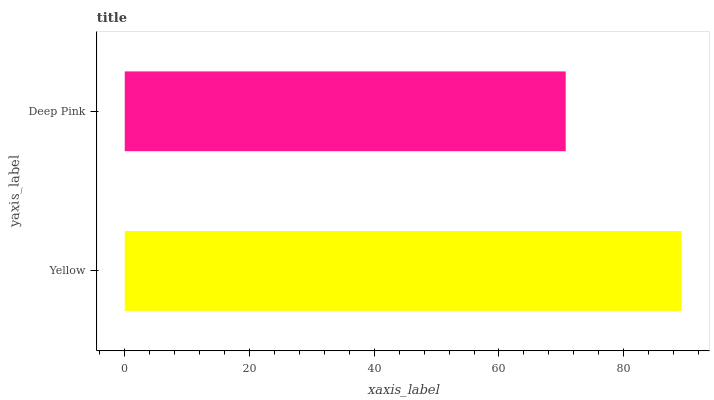Is Deep Pink the minimum?
Answer yes or no. Yes. Is Yellow the maximum?
Answer yes or no. Yes. Is Deep Pink the maximum?
Answer yes or no. No. Is Yellow greater than Deep Pink?
Answer yes or no. Yes. Is Deep Pink less than Yellow?
Answer yes or no. Yes. Is Deep Pink greater than Yellow?
Answer yes or no. No. Is Yellow less than Deep Pink?
Answer yes or no. No. Is Yellow the high median?
Answer yes or no. Yes. Is Deep Pink the low median?
Answer yes or no. Yes. Is Deep Pink the high median?
Answer yes or no. No. Is Yellow the low median?
Answer yes or no. No. 